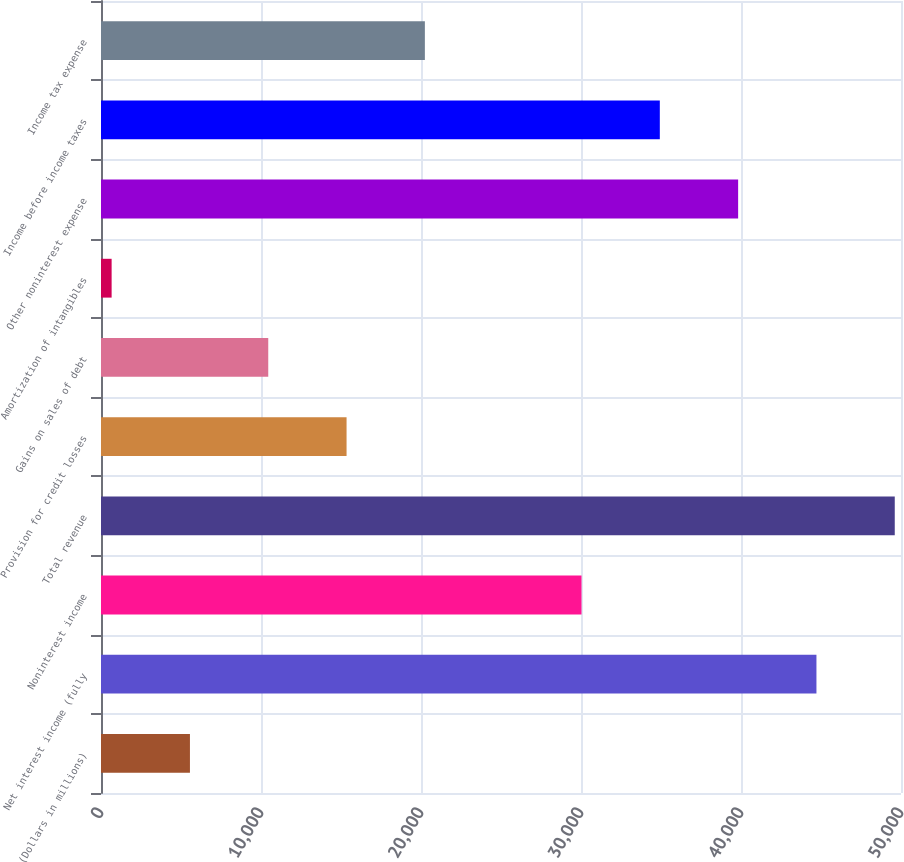Convert chart to OTSL. <chart><loc_0><loc_0><loc_500><loc_500><bar_chart><fcel>(Dollars in millions)<fcel>Net interest income (fully<fcel>Noninterest income<fcel>Total revenue<fcel>Provision for credit losses<fcel>Gains on sales of debt<fcel>Amortization of intangibles<fcel>Other noninterest expense<fcel>Income before income taxes<fcel>Income tax expense<nl><fcel>5558.6<fcel>44715.4<fcel>30031.6<fcel>49610<fcel>15347.8<fcel>10453.2<fcel>664<fcel>39820.8<fcel>34926.2<fcel>20242.4<nl></chart> 